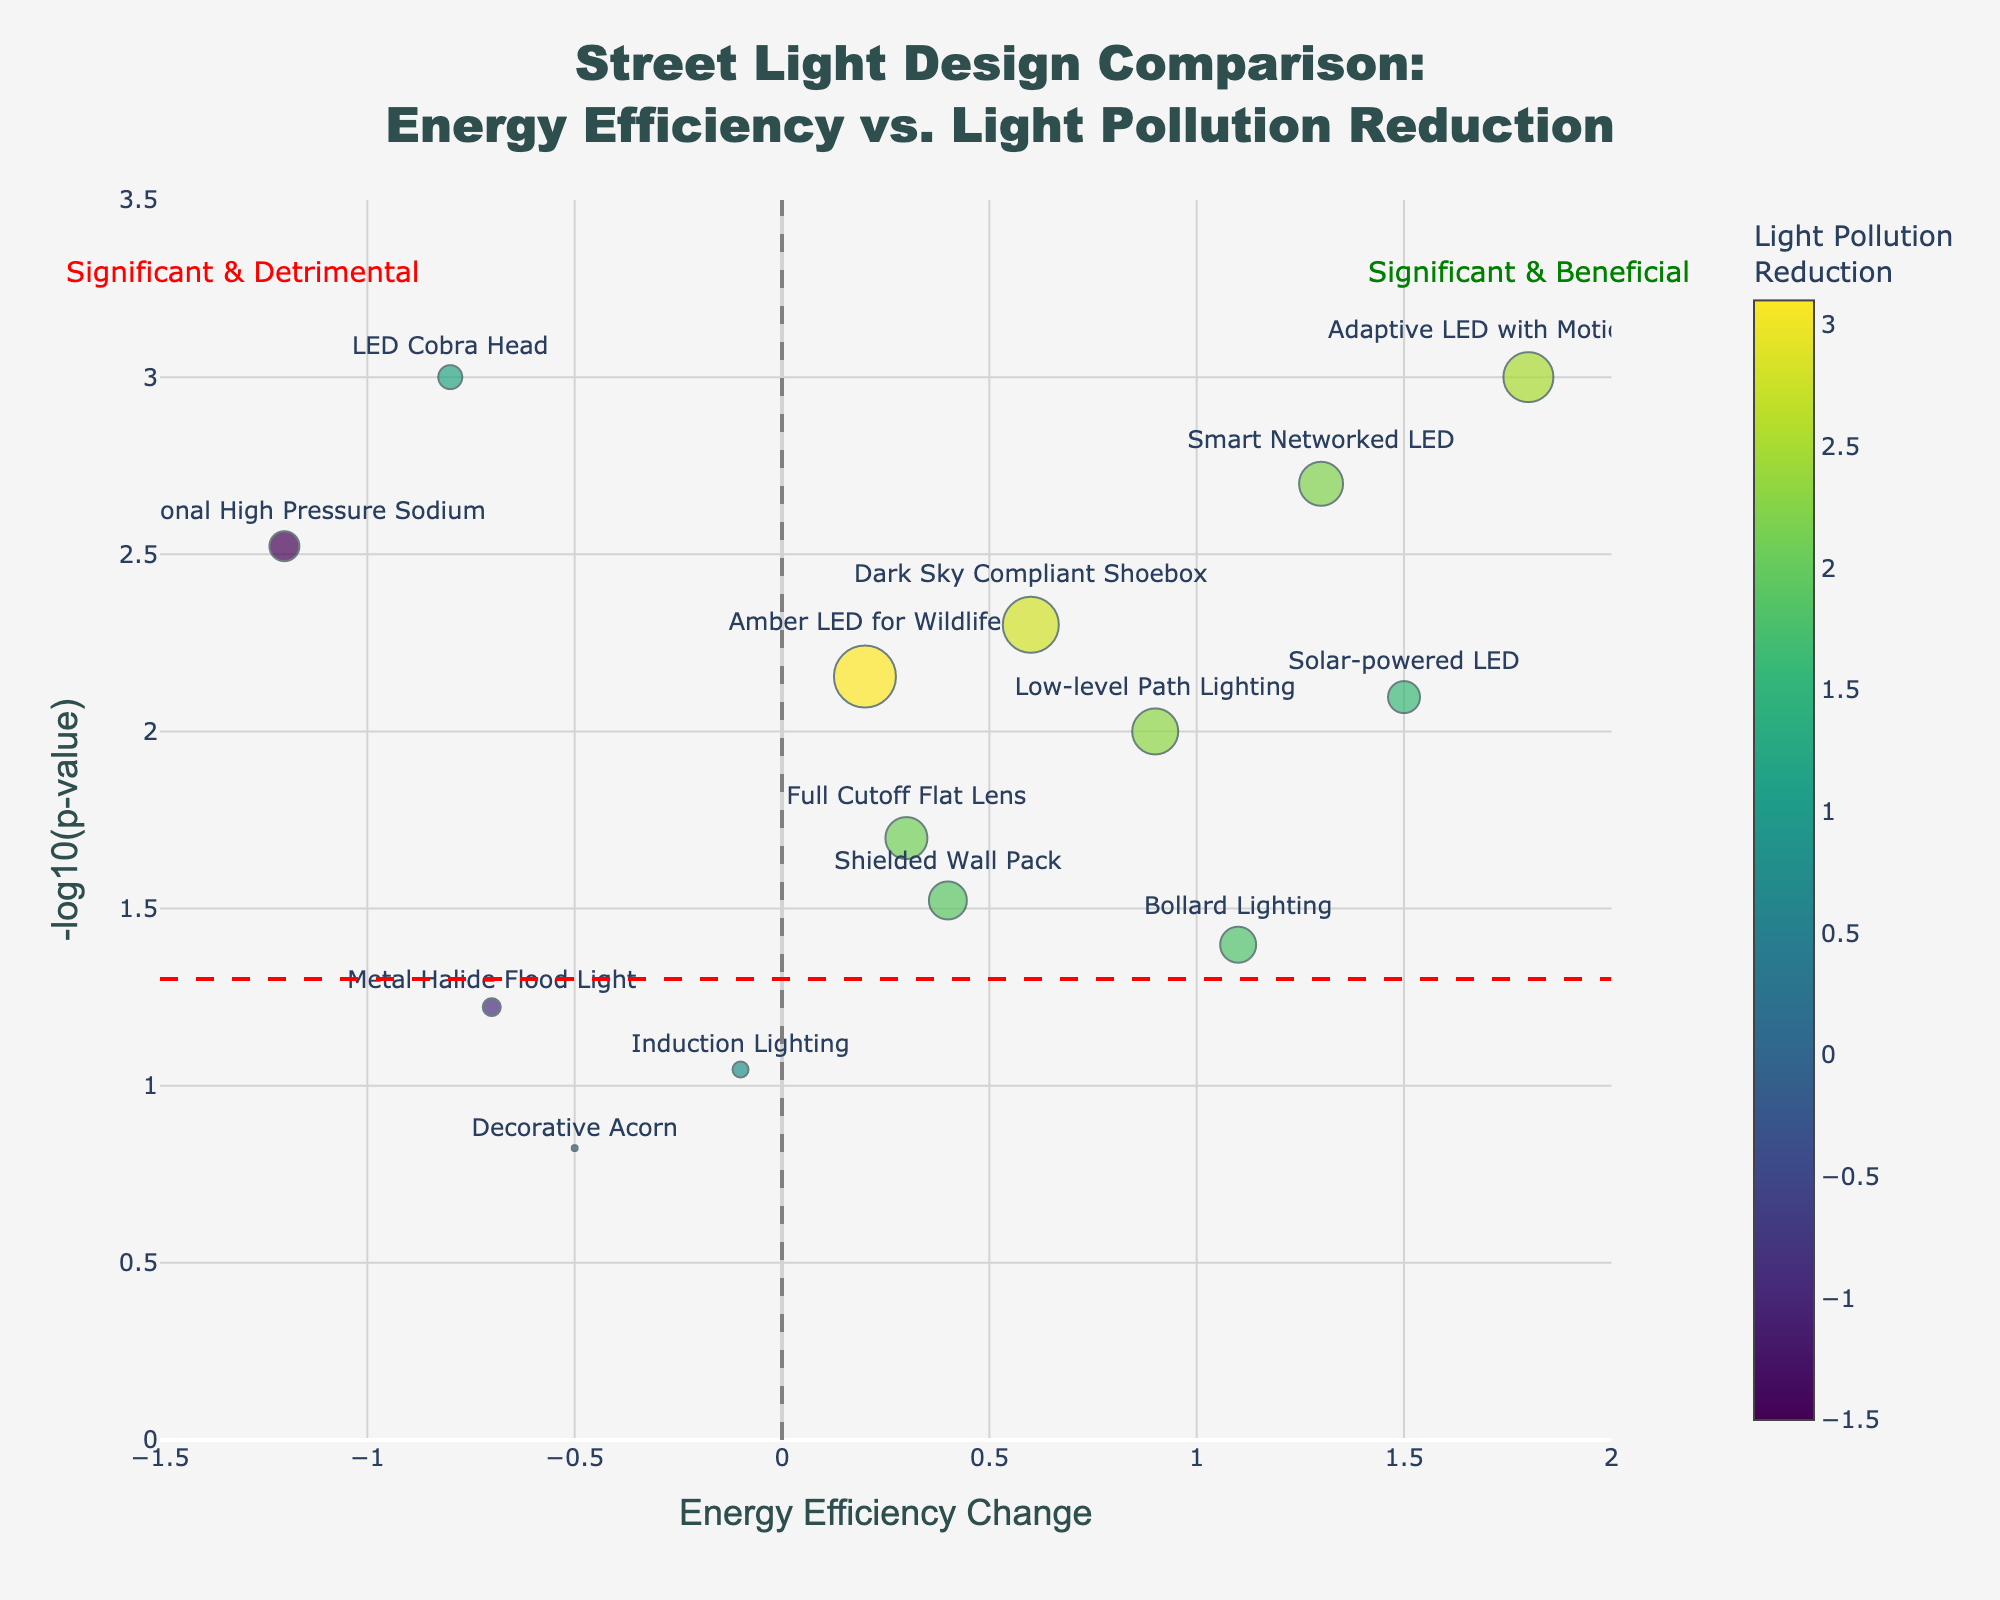What's the title of the figure? The title is prominently displayed at the top of the figure.
Answer: Street Light Design Comparison: Energy Efficiency vs. Light Pollution Reduction How many street light designs significantly reduce light pollution? Significant designs are those above the horizontal red dotted line indicating p-value < 0.05. Count the number of points above this line.
Answer: 10 Which street light design has the highest light pollution reduction? Look for the point with the largest marker and also check the hover information for precise values.
Answer: Amber LED for Wildlife What is the approximate p-value for the LED Cobra Head design? Locate the point labeled "LED Cobra Head" on the y-axis and use the scale of -log10(p-value) to estimate. The specific value in the hover info can also provide accuracy.
Answer: 0.001 Which two designs have a p-value close to 0.02? Find the designs near -log10(p-value) = 1.7 (since log10(0.02) ≈ 1.7) and check the hover information for these points.
Answer: Full Cutoff Flat Lens and Bollard Lighting What is the general trend of energy efficiency changes among designs with high light pollution reduction? Identify the designs with large marker sizes on the plot and observe their positions along the x-axis for overall energy efficiency changes.
Answer: Generally positive Which street light design has both positive energy efficiency and the highest light pollution reduction? Find the point with the highest light pollution reduction and check if it falls in the positive region of energy efficiency on the x-axis.
Answer: Adaptive LED with Motion Sensor How many designs show detrimental (negative) change in both energy efficiency and light pollution reduction? Look for points in the bottom-left quadrant of the plot where both x and y coordinates are negative.
Answer: 2 Which street light design is the most beneficial in terms of both significant and positive changes? Look for the top-right region of the plot marked "Significant & Beneficial" and check for the highest point there.
Answer: Adaptive LED with Motion Sensor Is the Solar-powered LED design statistically significant, and what is its impact on energy efficiency? Find the Solar-powered LED on the plot or hover information to check if it is above the red significance line and observe its position on the x-axis.
Answer: Yes, p-value is significant and energy efficiency change is positive 